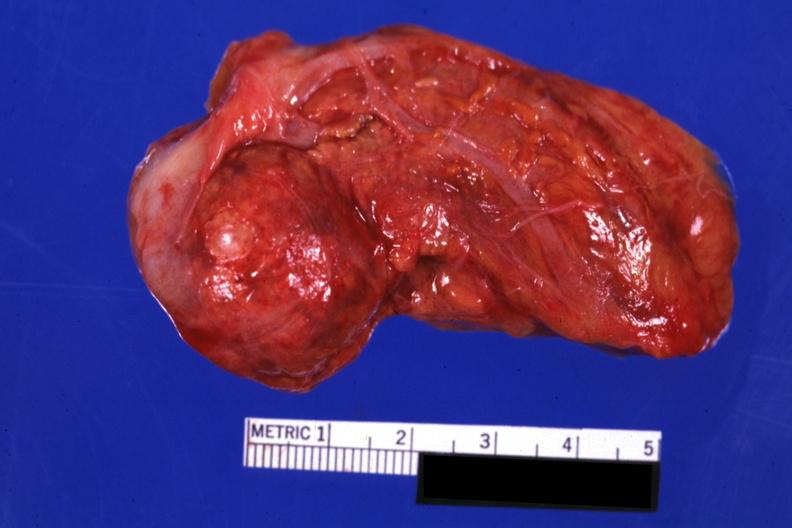what is present?
Answer the question using a single word or phrase. Cortical nodule 